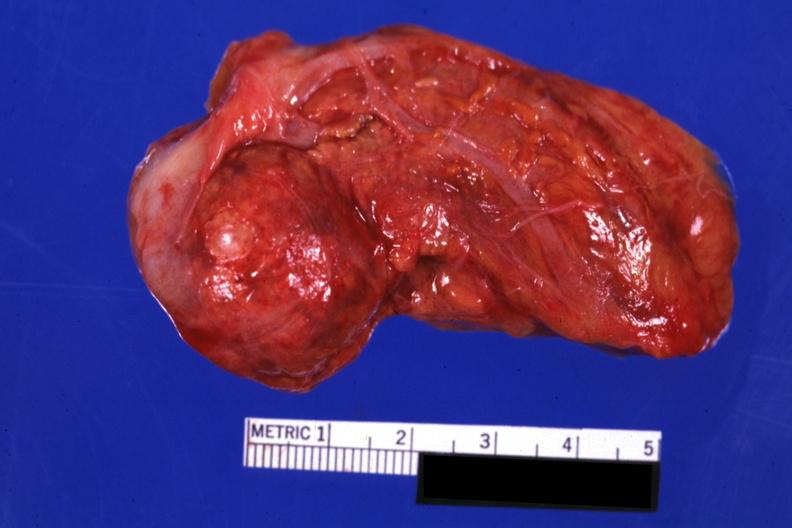what is present?
Answer the question using a single word or phrase. Cortical nodule 